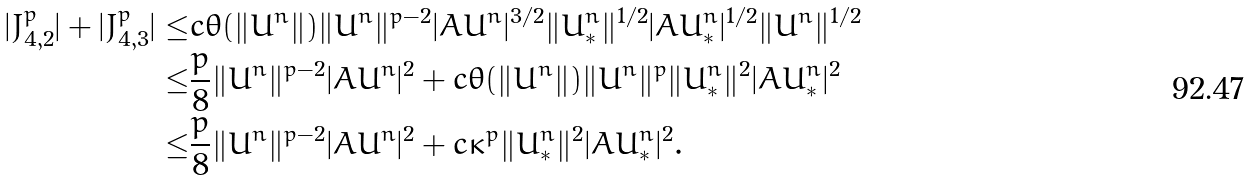Convert formula to latex. <formula><loc_0><loc_0><loc_500><loc_500>| J _ { 4 , 2 } ^ { p } | + | J _ { 4 , 3 } ^ { p } | \leq & c \theta ( \| \bar { U } ^ { n } \| ) \| \bar { U } ^ { n } \| ^ { p - 2 } | A \bar { U } ^ { n } | ^ { 3 / 2 } \| U ^ { n } _ { * } \| ^ { 1 / 2 } | A U ^ { n } _ { * } | ^ { 1 / 2 } \| \bar { U } ^ { n } \| ^ { 1 / 2 } \\ \leq & \frac { p } { 8 } \| \bar { U } ^ { n } \| ^ { p - 2 } | A \bar { U } ^ { n } | ^ { 2 } + c \theta ( \| \bar { U } ^ { n } \| ) \| \bar { U } ^ { n } \| ^ { p } \| U ^ { n } _ { * } \| ^ { 2 } | A U ^ { n } _ { * } | ^ { 2 } \\ \leq & \frac { p } { 8 } \| \bar { U } ^ { n } \| ^ { p - 2 } | A \bar { U } ^ { n } | ^ { 2 } + c \kappa ^ { p } \| U ^ { n } _ { * } \| ^ { 2 } | A U ^ { n } _ { * } | ^ { 2 } . \\</formula> 